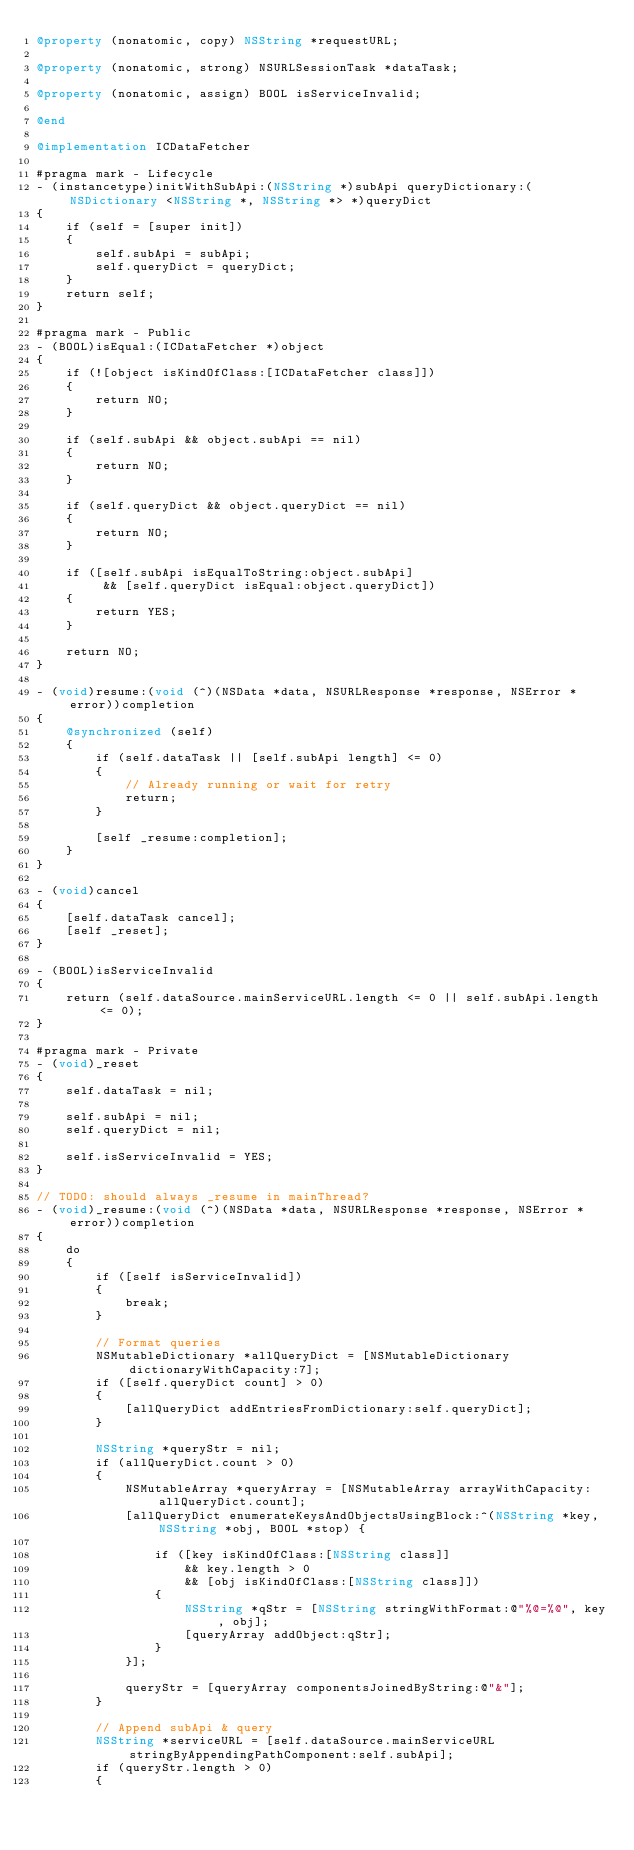<code> <loc_0><loc_0><loc_500><loc_500><_ObjectiveC_>@property (nonatomic, copy) NSString *requestURL;

@property (nonatomic, strong) NSURLSessionTask *dataTask;

@property (nonatomic, assign) BOOL isServiceInvalid;

@end

@implementation ICDataFetcher

#pragma mark - Lifecycle
- (instancetype)initWithSubApi:(NSString *)subApi queryDictionary:(NSDictionary <NSString *, NSString *> *)queryDict
{
    if (self = [super init])
    {
        self.subApi = subApi;
        self.queryDict = queryDict;
    }
    return self;
}

#pragma mark - Public
- (BOOL)isEqual:(ICDataFetcher *)object
{
    if (![object isKindOfClass:[ICDataFetcher class]])
    {
        return NO;
    }
    
    if (self.subApi && object.subApi == nil)
    {
        return NO;
    }
    
    if (self.queryDict && object.queryDict == nil)
    {
        return NO;
    }
    
    if ([self.subApi isEqualToString:object.subApi]
         && [self.queryDict isEqual:object.queryDict])
    {
        return YES;
    }

    return NO;
}

- (void)resume:(void (^)(NSData *data, NSURLResponse *response, NSError *error))completion
{
    @synchronized (self)
    {
        if (self.dataTask || [self.subApi length] <= 0)
        {
            // Already running or wait for retry
            return;
        }
        
        [self _resume:completion];
    }
}

- (void)cancel
{
    [self.dataTask cancel];
    [self _reset];
}

- (BOOL)isServiceInvalid
{
    return (self.dataSource.mainServiceURL.length <= 0 || self.subApi.length <= 0);
}

#pragma mark - Private
- (void)_reset
{
    self.dataTask = nil;
    
    self.subApi = nil;
    self.queryDict = nil;
    
    self.isServiceInvalid = YES;
}

// TODO: should always _resume in mainThread?
- (void)_resume:(void (^)(NSData *data, NSURLResponse *response, NSError *error))completion
{
    do
    {
        if ([self isServiceInvalid])
        {
            break;
        }
        
        // Format queries
        NSMutableDictionary *allQueryDict = [NSMutableDictionary dictionaryWithCapacity:7];
        if ([self.queryDict count] > 0)
        {
            [allQueryDict addEntriesFromDictionary:self.queryDict];
        }
        
        NSString *queryStr = nil;
        if (allQueryDict.count > 0)
        {
            NSMutableArray *queryArray = [NSMutableArray arrayWithCapacity:allQueryDict.count];
            [allQueryDict enumerateKeysAndObjectsUsingBlock:^(NSString *key, NSString *obj, BOOL *stop) {
                
                if ([key isKindOfClass:[NSString class]]
                    && key.length > 0
                    && [obj isKindOfClass:[NSString class]])
                {
                    NSString *qStr = [NSString stringWithFormat:@"%@=%@", key, obj];
                    [queryArray addObject:qStr];
                }
            }];
            
            queryStr = [queryArray componentsJoinedByString:@"&"];
        }
        
        // Append subApi & query
        NSString *serviceURL = [self.dataSource.mainServiceURL stringByAppendingPathComponent:self.subApi];
        if (queryStr.length > 0)
        {</code> 